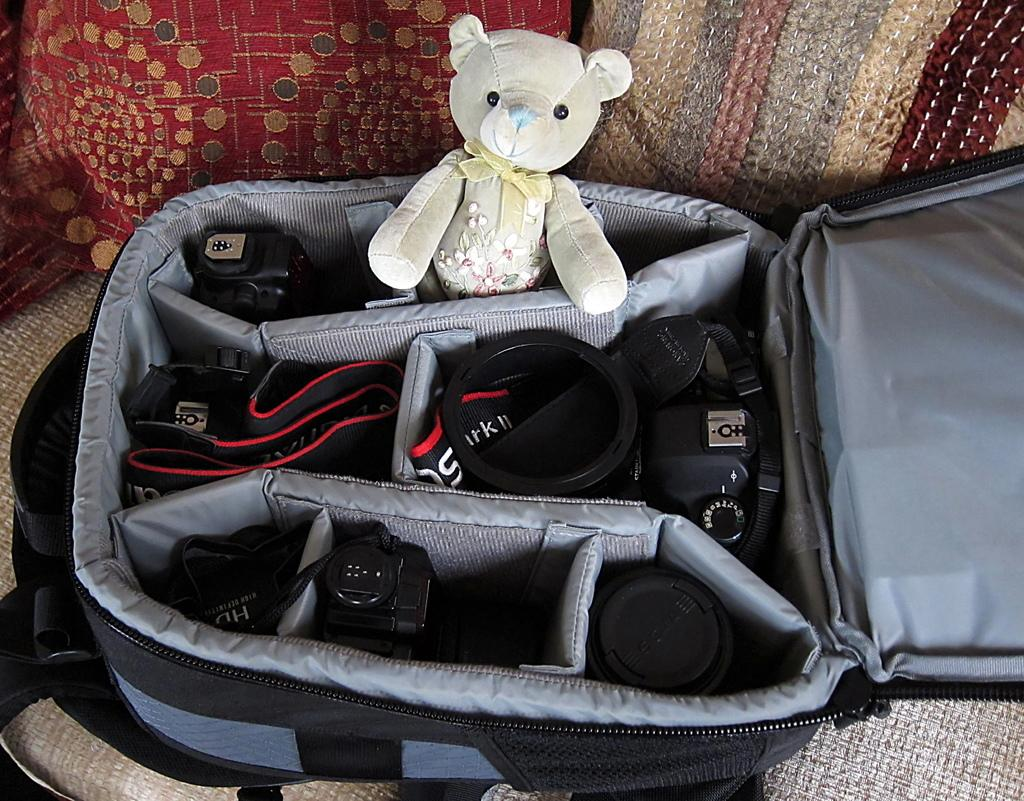What object is present in the image that can be used to carry items? There is a bag in the image that can be used to carry items. What items are inside the bag? The bag contains lenses and a camera. What other object is present in the image? There is a doll in the image. Where is the bag located in the image? The bag is placed on a sofa. What type of cake is being served on the doll's birthday in the image? There is no cake or birthday celebration depicted in the image; it features a bag, lenses, a camera, and a doll. What is the name of the doll in the image? The provided facts do not mention the name of the doll, so it cannot be determined from the image. 